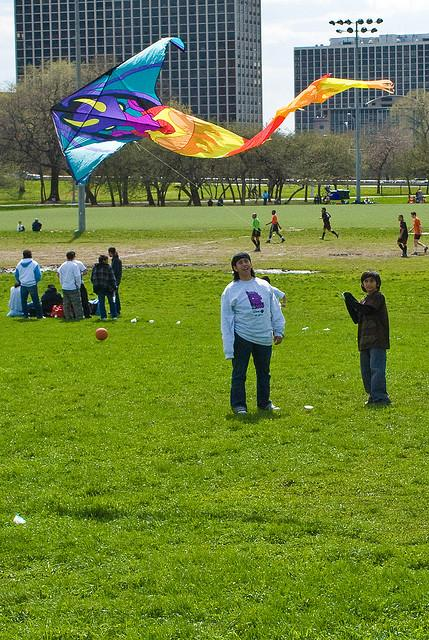The object in the air is in the shape of what animal?

Choices:
A) panda
B) lizard
C) rabbit
D) stingray stingray 